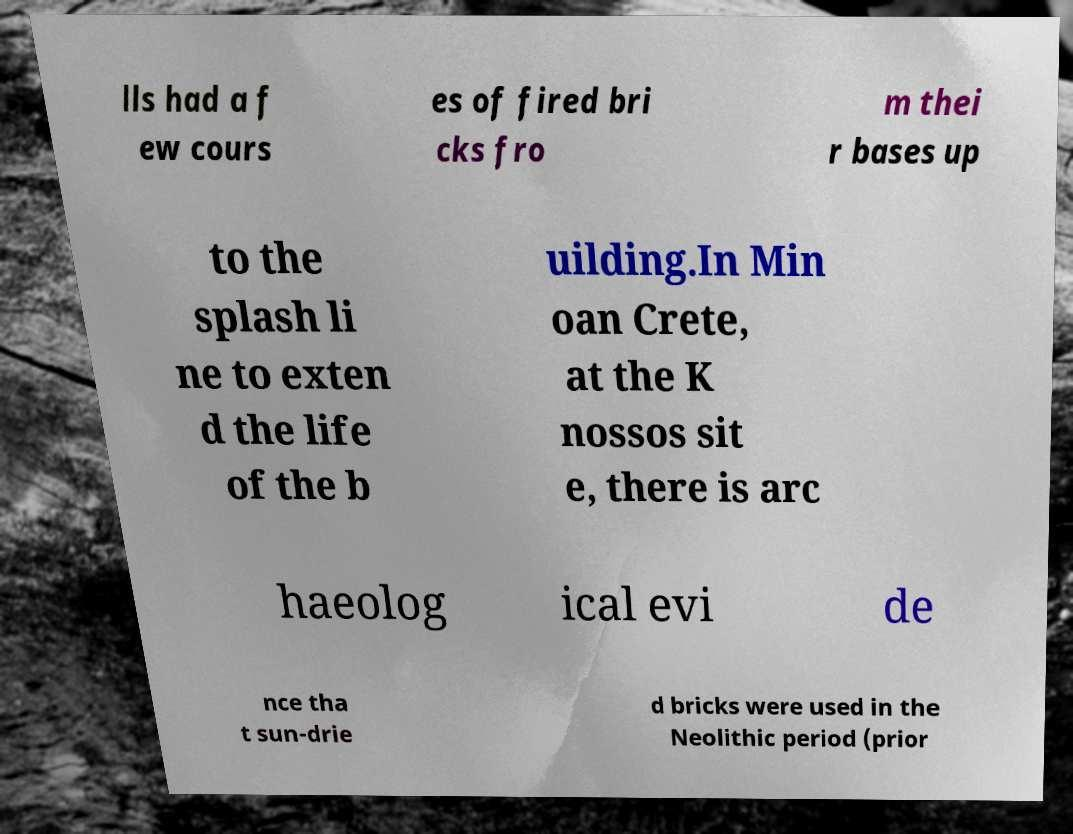I need the written content from this picture converted into text. Can you do that? lls had a f ew cours es of fired bri cks fro m thei r bases up to the splash li ne to exten d the life of the b uilding.In Min oan Crete, at the K nossos sit e, there is arc haeolog ical evi de nce tha t sun-drie d bricks were used in the Neolithic period (prior 